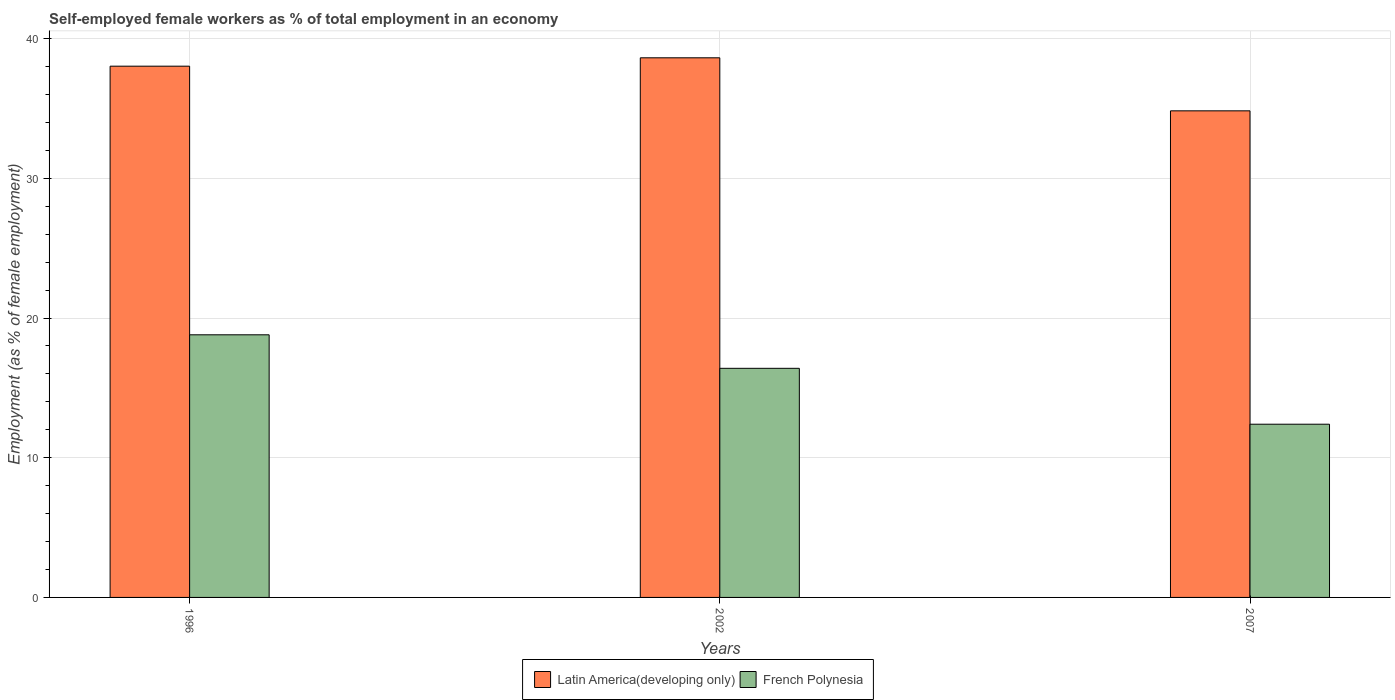How many different coloured bars are there?
Offer a terse response. 2. Are the number of bars per tick equal to the number of legend labels?
Offer a very short reply. Yes. How many bars are there on the 1st tick from the right?
Your answer should be compact. 2. In how many cases, is the number of bars for a given year not equal to the number of legend labels?
Give a very brief answer. 0. What is the percentage of self-employed female workers in Latin America(developing only) in 1996?
Your response must be concise. 38.03. Across all years, what is the maximum percentage of self-employed female workers in Latin America(developing only)?
Offer a terse response. 38.63. Across all years, what is the minimum percentage of self-employed female workers in Latin America(developing only)?
Your response must be concise. 34.83. In which year was the percentage of self-employed female workers in Latin America(developing only) maximum?
Ensure brevity in your answer.  2002. What is the total percentage of self-employed female workers in Latin America(developing only) in the graph?
Your answer should be very brief. 111.49. What is the difference between the percentage of self-employed female workers in Latin America(developing only) in 1996 and that in 2007?
Keep it short and to the point. 3.2. What is the difference between the percentage of self-employed female workers in Latin America(developing only) in 2002 and the percentage of self-employed female workers in French Polynesia in 1996?
Your response must be concise. 19.83. What is the average percentage of self-employed female workers in Latin America(developing only) per year?
Your response must be concise. 37.16. In the year 2002, what is the difference between the percentage of self-employed female workers in French Polynesia and percentage of self-employed female workers in Latin America(developing only)?
Provide a succinct answer. -22.23. What is the ratio of the percentage of self-employed female workers in French Polynesia in 2002 to that in 2007?
Your response must be concise. 1.32. Is the percentage of self-employed female workers in Latin America(developing only) in 2002 less than that in 2007?
Your answer should be compact. No. What is the difference between the highest and the second highest percentage of self-employed female workers in French Polynesia?
Make the answer very short. 2.4. What is the difference between the highest and the lowest percentage of self-employed female workers in Latin America(developing only)?
Provide a short and direct response. 3.8. Is the sum of the percentage of self-employed female workers in French Polynesia in 2002 and 2007 greater than the maximum percentage of self-employed female workers in Latin America(developing only) across all years?
Offer a terse response. No. What does the 2nd bar from the left in 2007 represents?
Ensure brevity in your answer.  French Polynesia. What does the 1st bar from the right in 1996 represents?
Your answer should be very brief. French Polynesia. How many bars are there?
Offer a very short reply. 6. Are all the bars in the graph horizontal?
Your answer should be very brief. No. How many years are there in the graph?
Your answer should be very brief. 3. What is the difference between two consecutive major ticks on the Y-axis?
Give a very brief answer. 10. Does the graph contain any zero values?
Your answer should be very brief. No. Where does the legend appear in the graph?
Your response must be concise. Bottom center. How many legend labels are there?
Give a very brief answer. 2. What is the title of the graph?
Your answer should be very brief. Self-employed female workers as % of total employment in an economy. What is the label or title of the Y-axis?
Your response must be concise. Employment (as % of female employment). What is the Employment (as % of female employment) in Latin America(developing only) in 1996?
Your answer should be very brief. 38.03. What is the Employment (as % of female employment) of French Polynesia in 1996?
Give a very brief answer. 18.8. What is the Employment (as % of female employment) of Latin America(developing only) in 2002?
Provide a short and direct response. 38.63. What is the Employment (as % of female employment) of French Polynesia in 2002?
Offer a terse response. 16.4. What is the Employment (as % of female employment) of Latin America(developing only) in 2007?
Your answer should be very brief. 34.83. What is the Employment (as % of female employment) in French Polynesia in 2007?
Provide a succinct answer. 12.4. Across all years, what is the maximum Employment (as % of female employment) of Latin America(developing only)?
Ensure brevity in your answer.  38.63. Across all years, what is the maximum Employment (as % of female employment) of French Polynesia?
Ensure brevity in your answer.  18.8. Across all years, what is the minimum Employment (as % of female employment) of Latin America(developing only)?
Your answer should be compact. 34.83. Across all years, what is the minimum Employment (as % of female employment) in French Polynesia?
Provide a short and direct response. 12.4. What is the total Employment (as % of female employment) of Latin America(developing only) in the graph?
Your answer should be very brief. 111.49. What is the total Employment (as % of female employment) of French Polynesia in the graph?
Offer a very short reply. 47.6. What is the difference between the Employment (as % of female employment) in Latin America(developing only) in 1996 and that in 2002?
Keep it short and to the point. -0.6. What is the difference between the Employment (as % of female employment) of French Polynesia in 1996 and that in 2002?
Your response must be concise. 2.4. What is the difference between the Employment (as % of female employment) of Latin America(developing only) in 1996 and that in 2007?
Provide a succinct answer. 3.2. What is the difference between the Employment (as % of female employment) of Latin America(developing only) in 2002 and that in 2007?
Offer a very short reply. 3.8. What is the difference between the Employment (as % of female employment) of Latin America(developing only) in 1996 and the Employment (as % of female employment) of French Polynesia in 2002?
Your response must be concise. 21.63. What is the difference between the Employment (as % of female employment) of Latin America(developing only) in 1996 and the Employment (as % of female employment) of French Polynesia in 2007?
Your response must be concise. 25.63. What is the difference between the Employment (as % of female employment) in Latin America(developing only) in 2002 and the Employment (as % of female employment) in French Polynesia in 2007?
Ensure brevity in your answer.  26.23. What is the average Employment (as % of female employment) of Latin America(developing only) per year?
Keep it short and to the point. 37.16. What is the average Employment (as % of female employment) of French Polynesia per year?
Ensure brevity in your answer.  15.87. In the year 1996, what is the difference between the Employment (as % of female employment) of Latin America(developing only) and Employment (as % of female employment) of French Polynesia?
Offer a terse response. 19.23. In the year 2002, what is the difference between the Employment (as % of female employment) in Latin America(developing only) and Employment (as % of female employment) in French Polynesia?
Offer a terse response. 22.23. In the year 2007, what is the difference between the Employment (as % of female employment) in Latin America(developing only) and Employment (as % of female employment) in French Polynesia?
Offer a terse response. 22.43. What is the ratio of the Employment (as % of female employment) in Latin America(developing only) in 1996 to that in 2002?
Your response must be concise. 0.98. What is the ratio of the Employment (as % of female employment) of French Polynesia in 1996 to that in 2002?
Your answer should be compact. 1.15. What is the ratio of the Employment (as % of female employment) in Latin America(developing only) in 1996 to that in 2007?
Your answer should be very brief. 1.09. What is the ratio of the Employment (as % of female employment) of French Polynesia in 1996 to that in 2007?
Keep it short and to the point. 1.52. What is the ratio of the Employment (as % of female employment) in Latin America(developing only) in 2002 to that in 2007?
Keep it short and to the point. 1.11. What is the ratio of the Employment (as % of female employment) in French Polynesia in 2002 to that in 2007?
Provide a short and direct response. 1.32. What is the difference between the highest and the second highest Employment (as % of female employment) of Latin America(developing only)?
Your response must be concise. 0.6. What is the difference between the highest and the second highest Employment (as % of female employment) in French Polynesia?
Provide a succinct answer. 2.4. What is the difference between the highest and the lowest Employment (as % of female employment) in Latin America(developing only)?
Provide a short and direct response. 3.8. What is the difference between the highest and the lowest Employment (as % of female employment) in French Polynesia?
Provide a short and direct response. 6.4. 